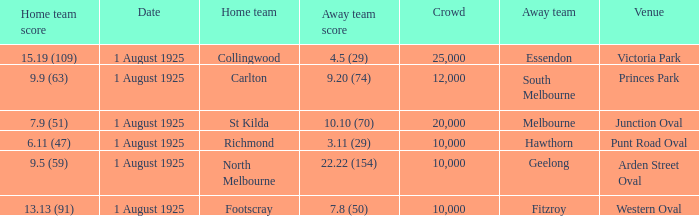5 (29), what was the audience size? 1.0. 